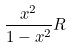<formula> <loc_0><loc_0><loc_500><loc_500>\frac { x ^ { 2 } } { 1 - x ^ { 2 } } R</formula> 